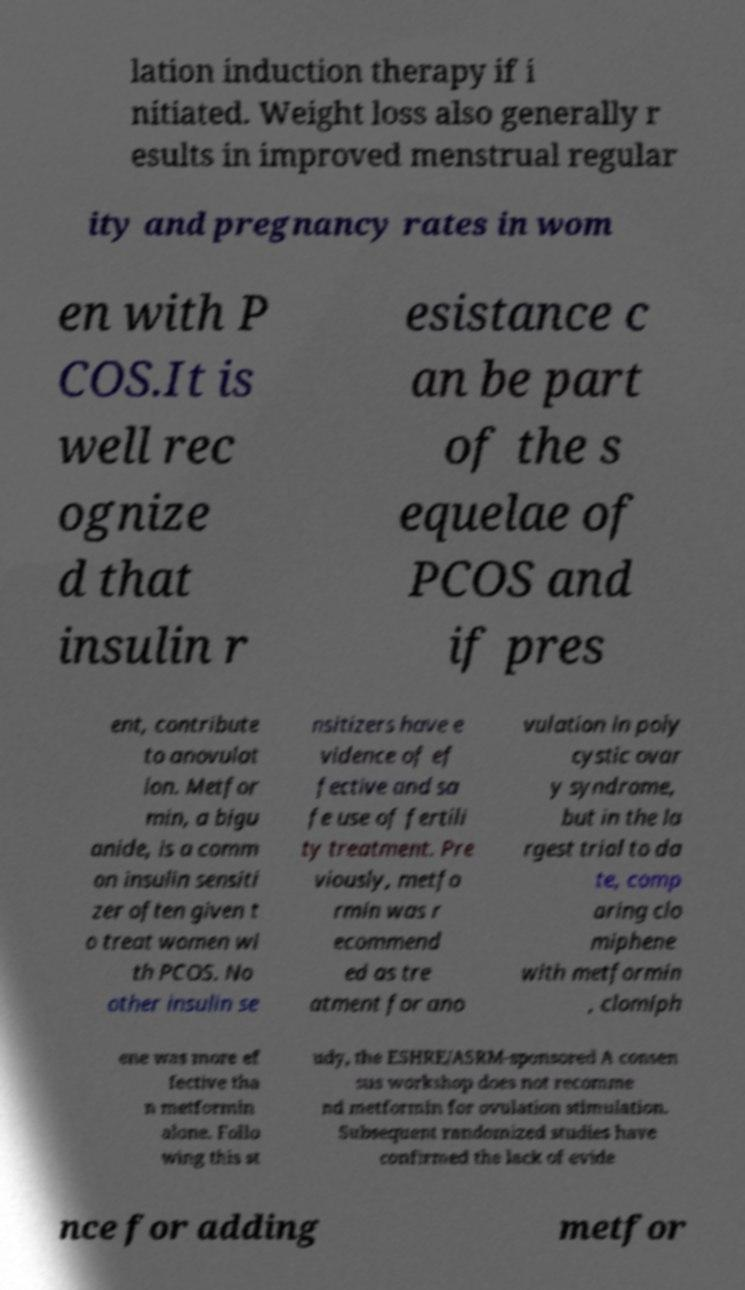Could you extract and type out the text from this image? lation induction therapy if i nitiated. Weight loss also generally r esults in improved menstrual regular ity and pregnancy rates in wom en with P COS.It is well rec ognize d that insulin r esistance c an be part of the s equelae of PCOS and if pres ent, contribute to anovulat ion. Metfor min, a bigu anide, is a comm on insulin sensiti zer often given t o treat women wi th PCOS. No other insulin se nsitizers have e vidence of ef fective and sa fe use of fertili ty treatment. Pre viously, metfo rmin was r ecommend ed as tre atment for ano vulation in poly cystic ovar y syndrome, but in the la rgest trial to da te, comp aring clo miphene with metformin , clomiph ene was more ef fective tha n metformin alone. Follo wing this st udy, the ESHRE/ASRM-sponsored A consen sus workshop does not recomme nd metformin for ovulation stimulation. Subsequent randomized studies have confirmed the lack of evide nce for adding metfor 